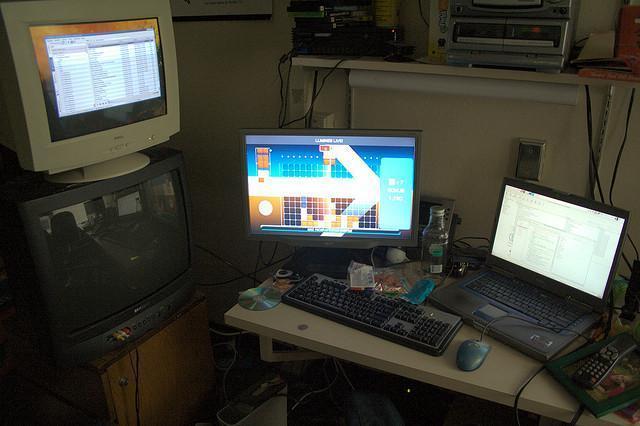How many screens are there?
Give a very brief answer. 3. How many keyboards can be seen?
Give a very brief answer. 2. How many tvs are there?
Give a very brief answer. 3. 